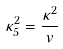Convert formula to latex. <formula><loc_0><loc_0><loc_500><loc_500>\kappa _ { 5 } ^ { 2 } = \frac { \kappa ^ { 2 } } { v }</formula> 